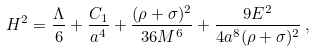Convert formula to latex. <formula><loc_0><loc_0><loc_500><loc_500>H ^ { 2 } = \frac { \Lambda } { 6 } + \frac { C _ { 1 } } { a ^ { 4 } } + \frac { ( \rho + \sigma ) ^ { 2 } } { 3 6 M ^ { 6 } } + \frac { 9 E ^ { 2 } } { 4 a ^ { 8 } ( \rho + \sigma ) ^ { 2 } } \, ,</formula> 